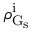<formula> <loc_0><loc_0><loc_500><loc_500>\rho _ { G _ { s } } ^ { i }</formula> 